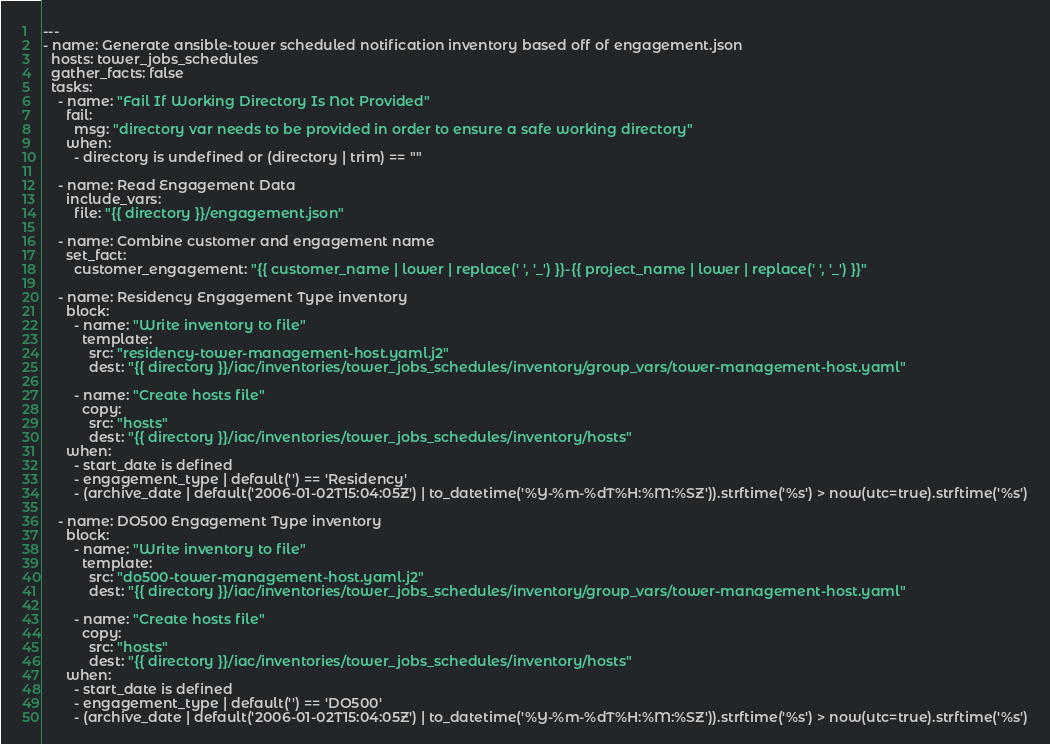Convert code to text. <code><loc_0><loc_0><loc_500><loc_500><_YAML_>---
- name: Generate ansible-tower scheduled notification inventory based off of engagement.json
  hosts: tower_jobs_schedules
  gather_facts: false
  tasks:
    - name: "Fail If Working Directory Is Not Provided"
      fail:
        msg: "directory var needs to be provided in order to ensure a safe working directory"
      when:
        - directory is undefined or (directory | trim) == ""

    - name: Read Engagement Data
      include_vars:
        file: "{{ directory }}/engagement.json"

    - name: Combine customer and engagement name
      set_fact:
        customer_engagement: "{{ customer_name | lower | replace(' ', '_') }}-{{ project_name | lower | replace(' ', '_') }}"

    - name: Residency Engagement Type inventory
      block:
        - name: "Write inventory to file"
          template:
            src: "residency-tower-management-host.yaml.j2"
            dest: "{{ directory }}/iac/inventories/tower_jobs_schedules/inventory/group_vars/tower-management-host.yaml"

        - name: "Create hosts file"
          copy:
            src: "hosts"
            dest: "{{ directory }}/iac/inventories/tower_jobs_schedules/inventory/hosts"
      when:
        - start_date is defined
        - engagement_type | default('') == 'Residency'
        - (archive_date | default('2006-01-02T15:04:05Z') | to_datetime('%Y-%m-%dT%H:%M:%SZ')).strftime('%s') > now(utc=true).strftime('%s')

    - name: DO500 Engagement Type inventory
      block:
        - name: "Write inventory to file"
          template:
            src: "do500-tower-management-host.yaml.j2"
            dest: "{{ directory }}/iac/inventories/tower_jobs_schedules/inventory/group_vars/tower-management-host.yaml"

        - name: "Create hosts file"
          copy:
            src: "hosts"
            dest: "{{ directory }}/iac/inventories/tower_jobs_schedules/inventory/hosts"
      when:
        - start_date is defined
        - engagement_type | default('') == 'DO500'
        - (archive_date | default('2006-01-02T15:04:05Z') | to_datetime('%Y-%m-%dT%H:%M:%SZ')).strftime('%s') > now(utc=true).strftime('%s')
</code> 